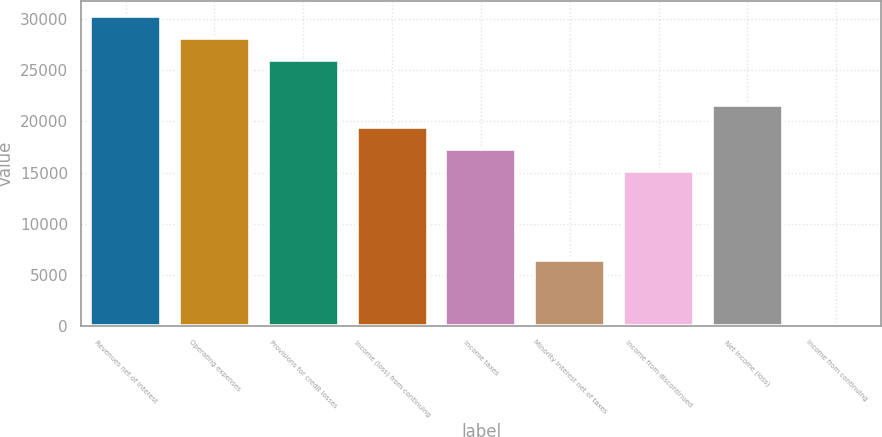Convert chart to OTSL. <chart><loc_0><loc_0><loc_500><loc_500><bar_chart><fcel>Revenues net of interest<fcel>Operating expenses<fcel>Provisions for credit losses<fcel>Income (loss) from continuing<fcel>Income taxes<fcel>Minority interest net of taxes<fcel>Income from discontinued<fcel>Net income (loss)<fcel>Income from continuing<nl><fcel>30295.9<fcel>28131.9<fcel>25968<fcel>19476.1<fcel>17312.1<fcel>6492.31<fcel>15148.1<fcel>21640<fcel>0.43<nl></chart> 